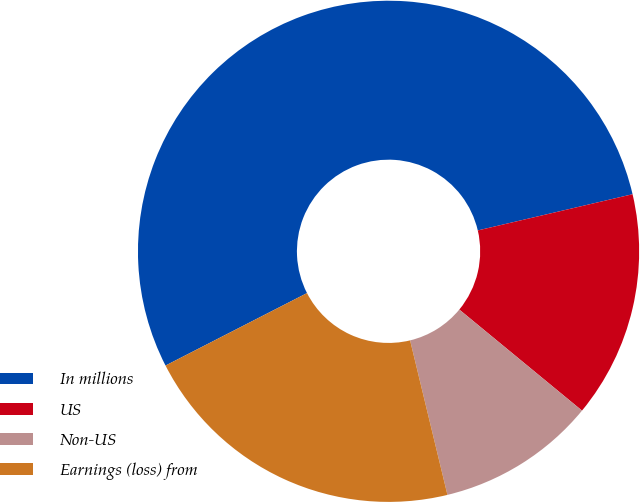<chart> <loc_0><loc_0><loc_500><loc_500><pie_chart><fcel>In millions<fcel>US<fcel>Non-US<fcel>Earnings (loss) from<nl><fcel>53.87%<fcel>14.62%<fcel>10.26%<fcel>21.24%<nl></chart> 